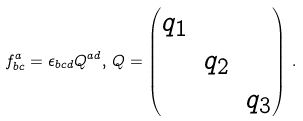Convert formula to latex. <formula><loc_0><loc_0><loc_500><loc_500>f _ { b c } ^ { a } = \epsilon _ { b c d } Q ^ { a d } , \, Q = \begin{pmatrix} q _ { 1 } & \ & \ \\ \ & q _ { 2 } & \ \\ \ & \ & q _ { 3 } \end{pmatrix} \, .</formula> 